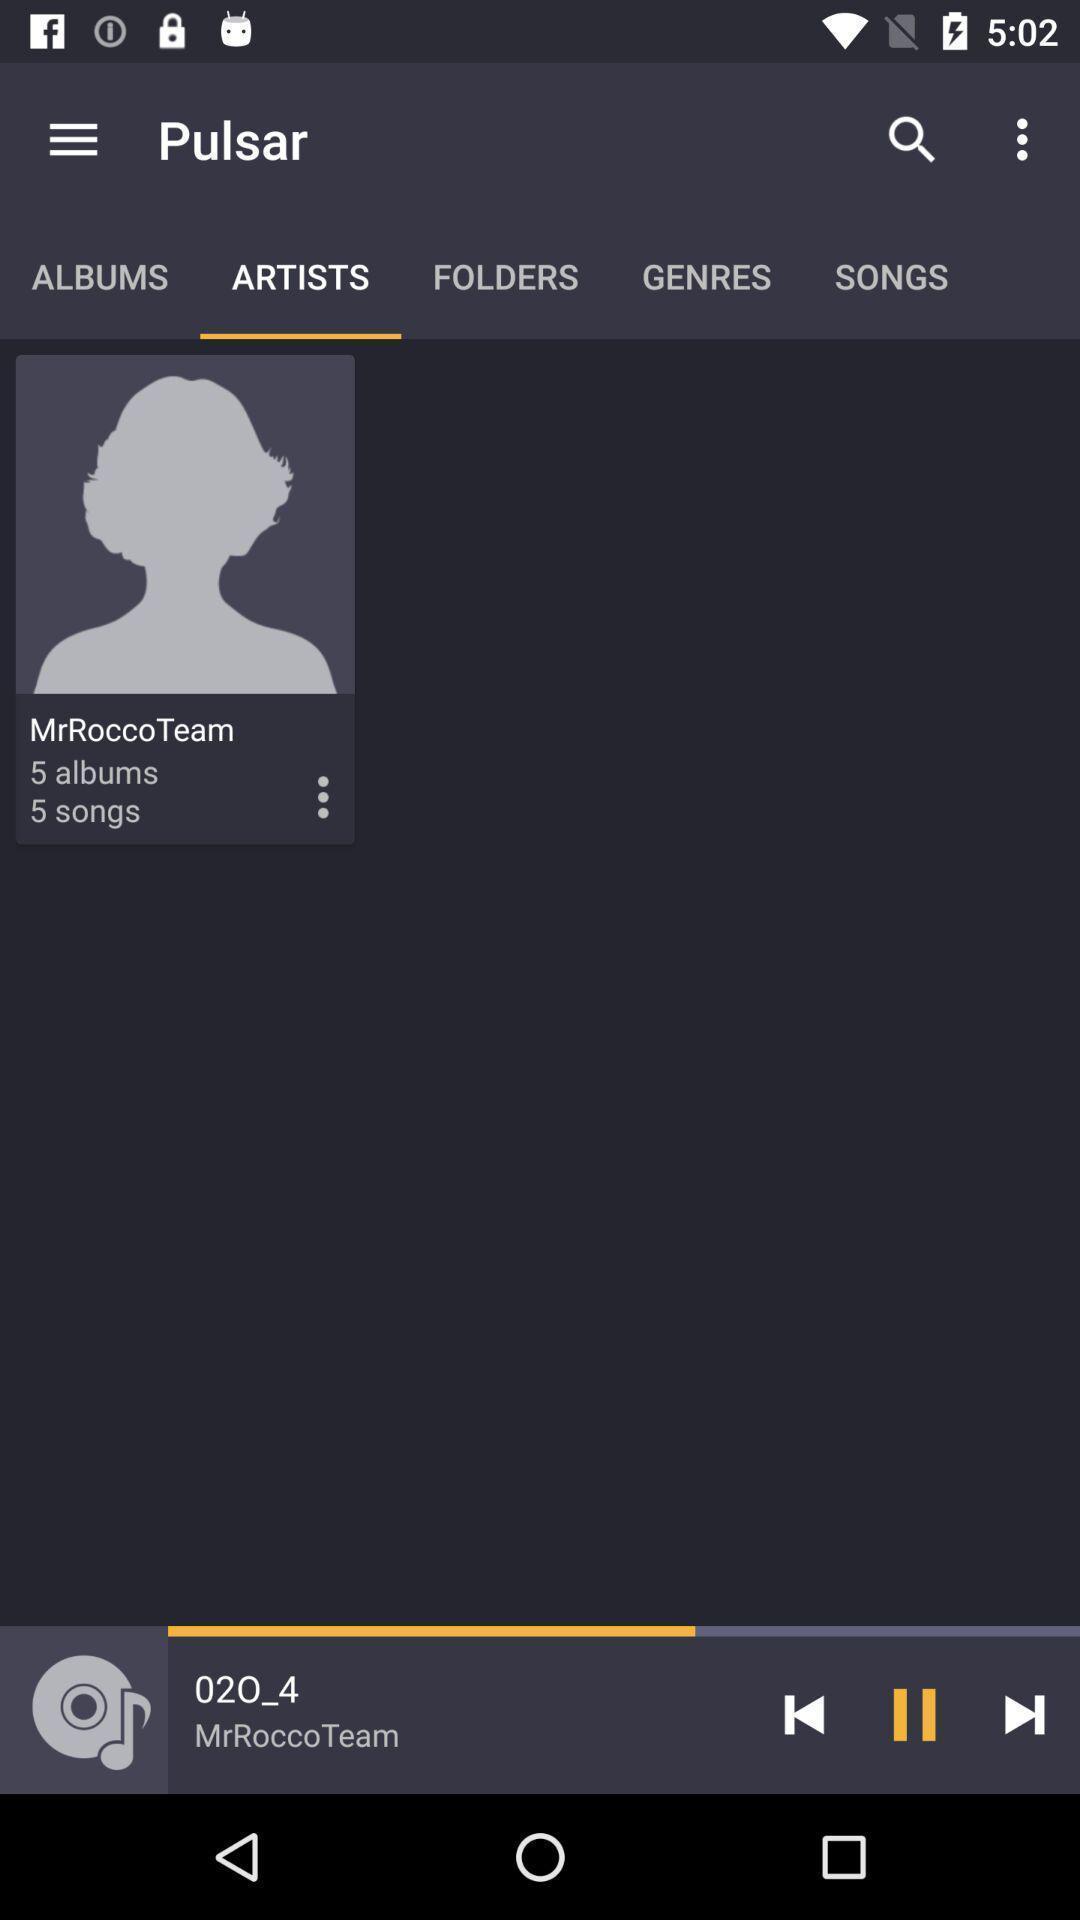What is the overall content of this screenshot? Screen displaying multiple song control options in a music application. 